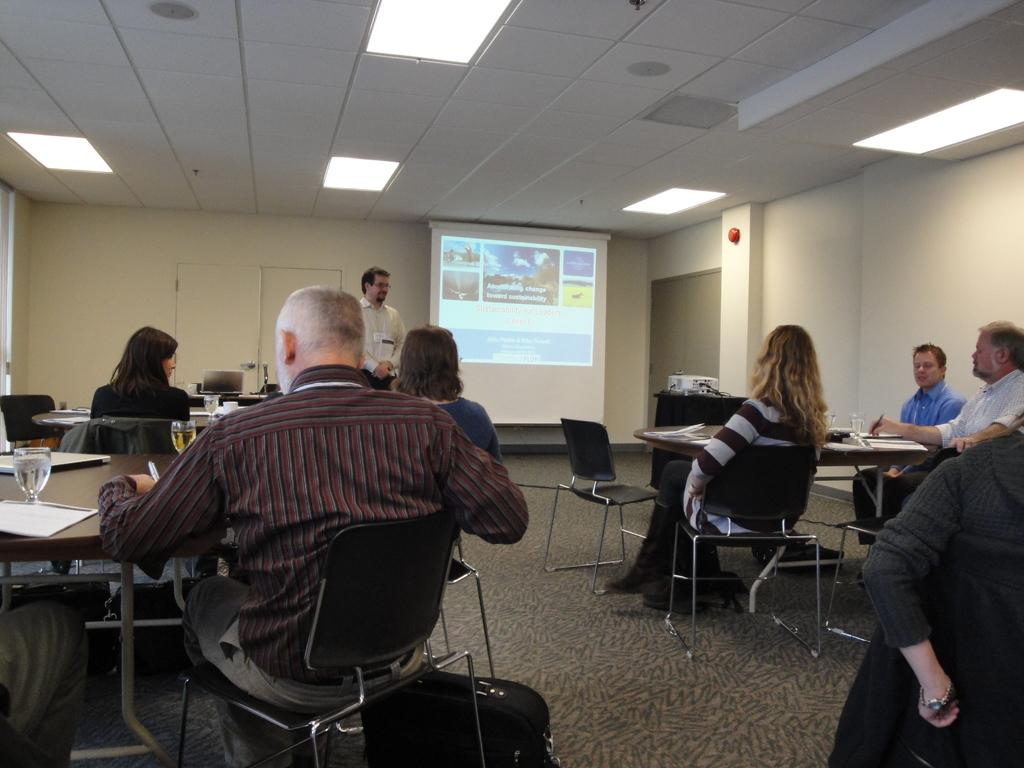What are the people in the image doing? There is a group of people sitting in chairs in the image. Is there anyone standing among the seated people? Yes, there is a person standing in the middle. What can be seen at the top of the image? There is a light at the top of the image. What type of ray is swimming in the background of the image? There is no ray present in the image; it features a group of people sitting and standing with a light at the top. 